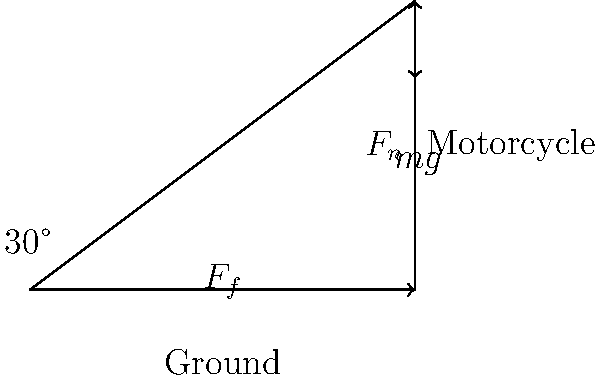In a typical motorcycle crash scenario, a rider slides along the ground at a 30° angle as shown in the diagram. If the coefficient of friction between the rider and the ground is 0.6, what is the magnitude of the normal force ($F_n$) acting on the rider in terms of the rider's weight ($mg$)? To solve this problem, we'll follow these steps:

1) First, let's identify the forces acting on the rider:
   - Weight ($mg$) acting downward
   - Normal force ($F_n$) perpendicular to the ground
   - Friction force ($F_f$) parallel to the ground

2) We can resolve the weight into components parallel and perpendicular to the ground:
   - Perpendicular component: $mg \cos 30°$
   - Parallel component: $mg \sin 30°$

3) The normal force $F_n$ balances the perpendicular component of weight:
   $F_n = mg \cos 30°$

4) The friction force opposes motion and is given by:
   $F_f = \mu F_n$ where $\mu$ is the coefficient of friction

5) The friction force balances the parallel component of weight:
   $F_f = mg \sin 30°$

6) Substituting the expression for $F_f$:
   $\mu F_n = mg \sin 30°$

7) Substituting the expression for $F_n$ from step 3:
   $\mu (mg \cos 30°) = mg \sin 30°$

8) Simplifying:
   $\mu \cos 30° = \sin 30°$

9) Solving for $\mu$:
   $\mu = \frac{\sin 30°}{\cos 30°} = \tan 30° \approx 0.577$

10) Since the given coefficient of friction (0.6) is greater than this value, the rider will come to a stop eventually.

11) The magnitude of the normal force is:
    $F_n = mg \cos 30° = mg \cdot \frac{\sqrt{3}}{2}$

Therefore, the magnitude of the normal force is $\frac{\sqrt{3}}{2}mg$.
Answer: $\frac{\sqrt{3}}{2}mg$ 